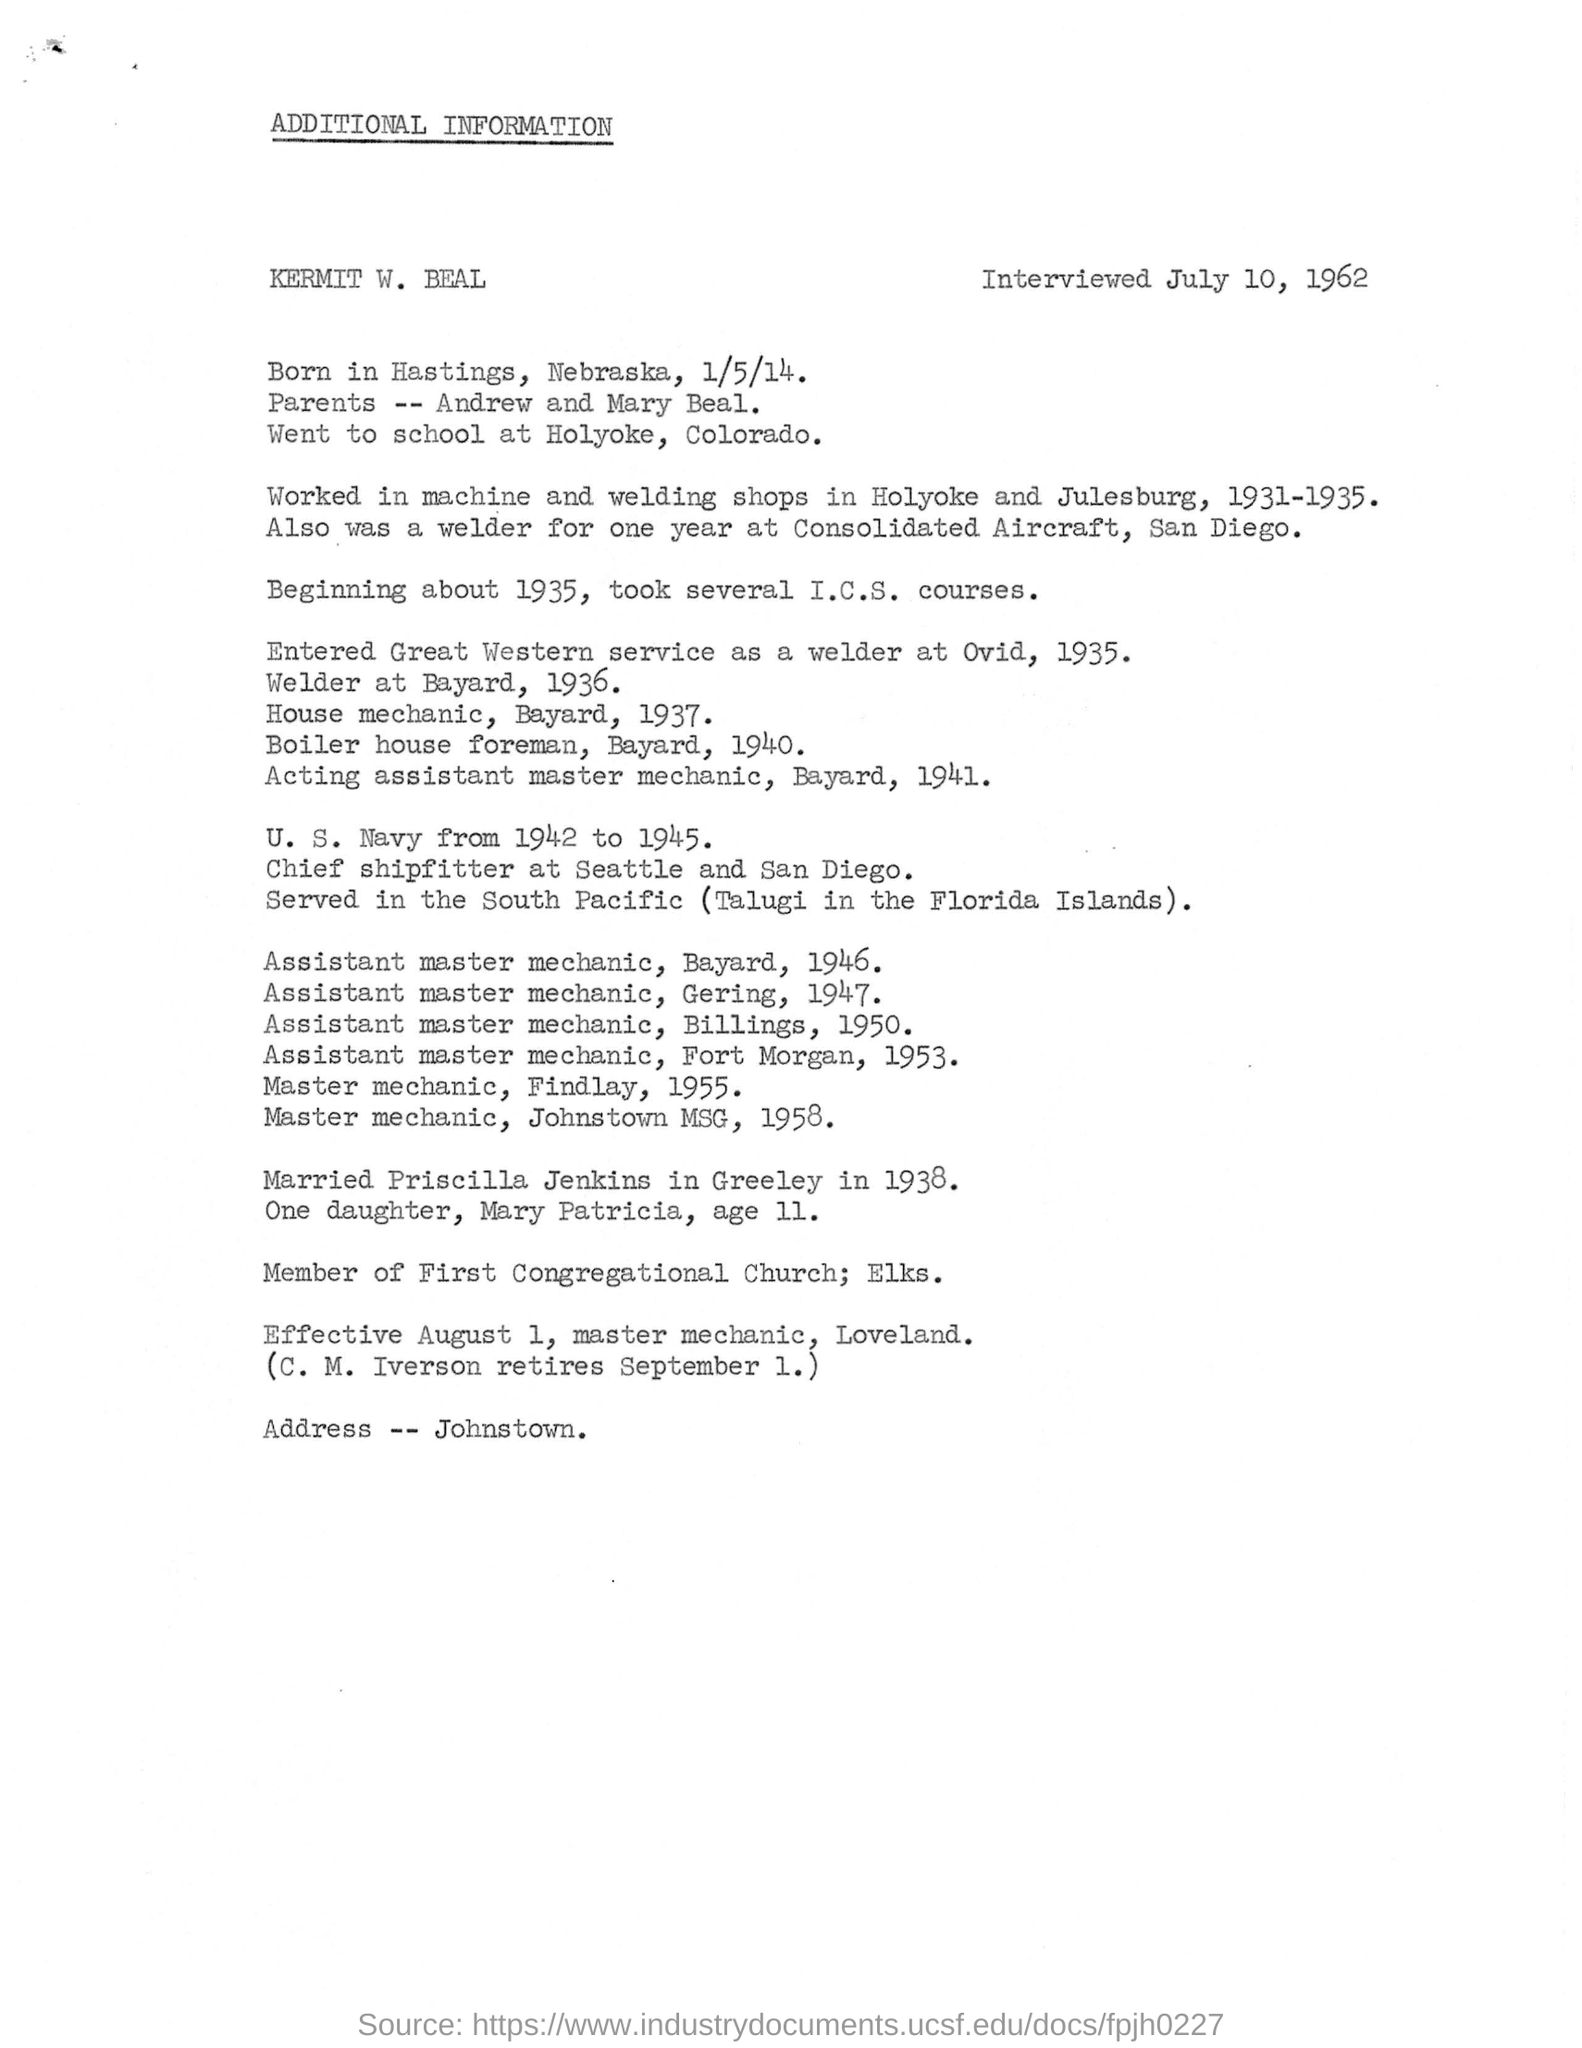What is the date of birth of Kermit W. Beal?
Your answer should be very brief. 1/5/14. What is the place of birth of Kermit W. Beal?
Your answer should be very brief. Hastings, Nebraska. When did Kermit W. Beal got married?
Ensure brevity in your answer.  1938. During which period, Kermit W. Beal served in the U. S. Navy?
Keep it short and to the point. 1942 to 1945. 